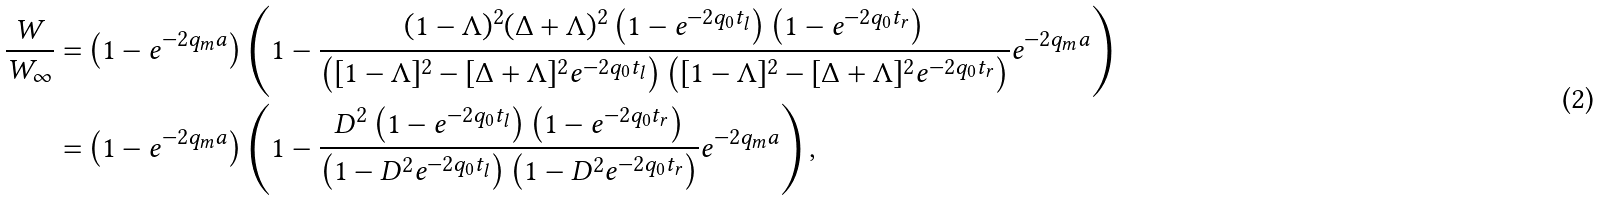Convert formula to latex. <formula><loc_0><loc_0><loc_500><loc_500>\frac { W } { W _ { \infty } } = & \left ( 1 - e ^ { - 2 q _ { m } a } \right ) \left ( 1 - \frac { ( 1 - \Lambda ) ^ { 2 } ( \Delta + \Lambda ) ^ { 2 } \left ( 1 - e ^ { - 2 q _ { 0 } t _ { l } } \right ) \left ( 1 - e ^ { - 2 q _ { 0 } t _ { r } } \right ) } { \left ( [ 1 - \Lambda ] ^ { 2 } - [ \Delta + \Lambda ] ^ { 2 } e ^ { - 2 q _ { 0 } t _ { l } } \right ) \left ( [ 1 - \Lambda ] ^ { 2 } - [ \Delta + \Lambda ] ^ { 2 } e ^ { - 2 q _ { 0 } t _ { r } } \right ) } e ^ { - 2 q _ { m } a } \right ) \\ = & \left ( 1 - e ^ { - 2 q _ { m } a } \right ) \left ( 1 - \frac { D ^ { 2 } \left ( 1 - e ^ { - 2 q _ { 0 } t _ { l } } \right ) \left ( 1 - e ^ { - 2 q _ { 0 } t _ { r } } \right ) } { \left ( 1 - D ^ { 2 } e ^ { - 2 q _ { 0 } t _ { l } } \right ) \left ( 1 - D ^ { 2 } e ^ { - 2 q _ { 0 } t _ { r } } \right ) } e ^ { - 2 q _ { m } a } \right ) ,</formula> 